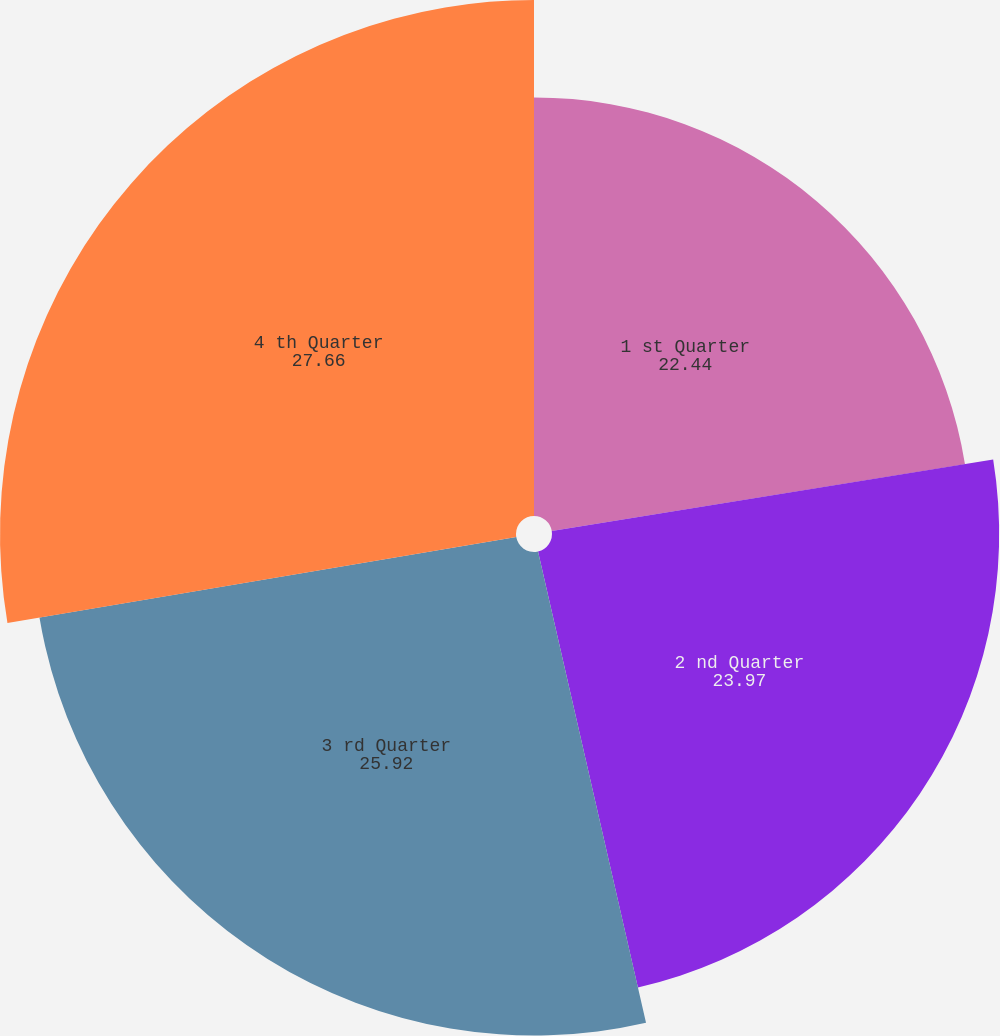<chart> <loc_0><loc_0><loc_500><loc_500><pie_chart><fcel>1 st Quarter<fcel>2 nd Quarter<fcel>3 rd Quarter<fcel>4 th Quarter<nl><fcel>22.44%<fcel>23.97%<fcel>25.92%<fcel>27.66%<nl></chart> 